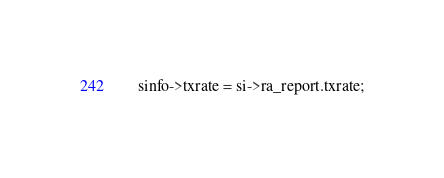<code> <loc_0><loc_0><loc_500><loc_500><_C_>
	sinfo->txrate = si->ra_report.txrate;</code> 